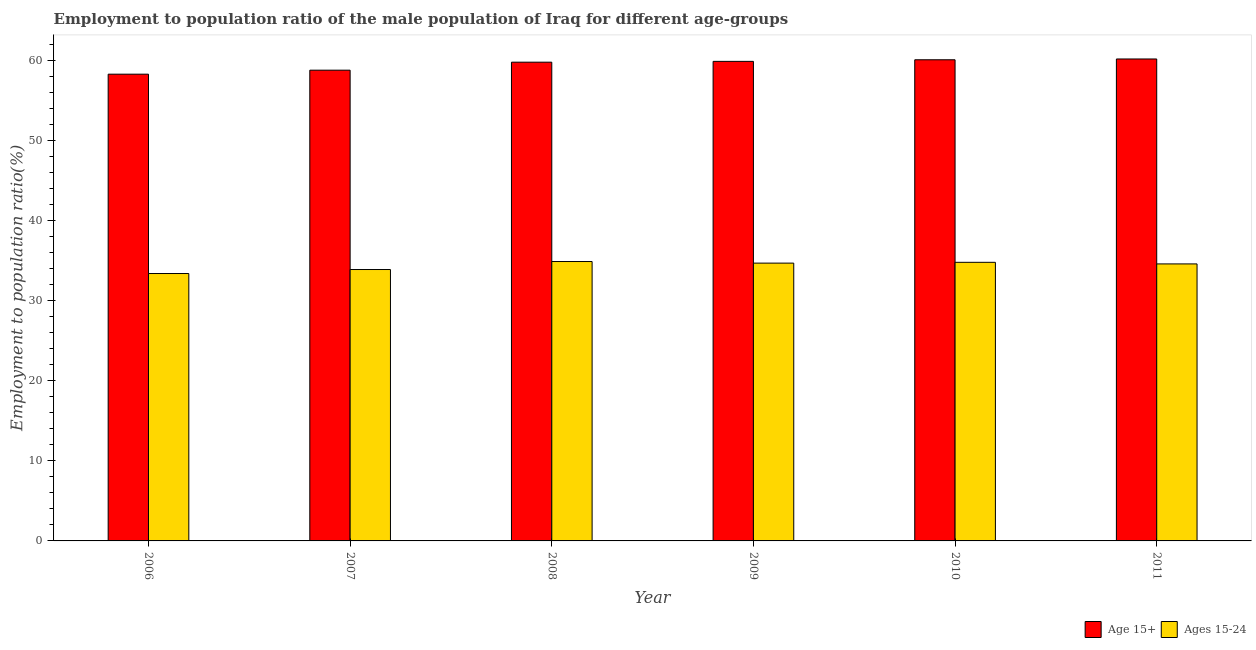How many bars are there on the 3rd tick from the left?
Make the answer very short. 2. How many bars are there on the 2nd tick from the right?
Provide a succinct answer. 2. What is the employment to population ratio(age 15+) in 2009?
Provide a succinct answer. 59.9. Across all years, what is the maximum employment to population ratio(age 15-24)?
Your answer should be very brief. 34.9. Across all years, what is the minimum employment to population ratio(age 15+)?
Ensure brevity in your answer.  58.3. In which year was the employment to population ratio(age 15+) maximum?
Keep it short and to the point. 2011. In which year was the employment to population ratio(age 15-24) minimum?
Keep it short and to the point. 2006. What is the total employment to population ratio(age 15+) in the graph?
Your answer should be very brief. 357.1. What is the difference between the employment to population ratio(age 15-24) in 2010 and that in 2011?
Provide a succinct answer. 0.2. What is the difference between the employment to population ratio(age 15-24) in 2010 and the employment to population ratio(age 15+) in 2007?
Give a very brief answer. 0.9. What is the average employment to population ratio(age 15-24) per year?
Provide a succinct answer. 34.38. In the year 2007, what is the difference between the employment to population ratio(age 15+) and employment to population ratio(age 15-24)?
Ensure brevity in your answer.  0. In how many years, is the employment to population ratio(age 15-24) greater than 28 %?
Provide a succinct answer. 6. What is the ratio of the employment to population ratio(age 15+) in 2007 to that in 2009?
Your answer should be very brief. 0.98. Is the employment to population ratio(age 15-24) in 2006 less than that in 2009?
Keep it short and to the point. Yes. What is the difference between the highest and the second highest employment to population ratio(age 15-24)?
Your answer should be compact. 0.1. What is the difference between the highest and the lowest employment to population ratio(age 15+)?
Your response must be concise. 1.9. Is the sum of the employment to population ratio(age 15-24) in 2006 and 2008 greater than the maximum employment to population ratio(age 15+) across all years?
Your answer should be compact. Yes. What does the 1st bar from the left in 2008 represents?
Your answer should be compact. Age 15+. What does the 1st bar from the right in 2008 represents?
Your response must be concise. Ages 15-24. How many bars are there?
Make the answer very short. 12. How many years are there in the graph?
Provide a short and direct response. 6. Does the graph contain any zero values?
Offer a very short reply. No. Does the graph contain grids?
Keep it short and to the point. No. How are the legend labels stacked?
Your answer should be compact. Horizontal. What is the title of the graph?
Offer a terse response. Employment to population ratio of the male population of Iraq for different age-groups. What is the label or title of the Y-axis?
Keep it short and to the point. Employment to population ratio(%). What is the Employment to population ratio(%) of Age 15+ in 2006?
Offer a very short reply. 58.3. What is the Employment to population ratio(%) of Ages 15-24 in 2006?
Give a very brief answer. 33.4. What is the Employment to population ratio(%) in Age 15+ in 2007?
Provide a short and direct response. 58.8. What is the Employment to population ratio(%) in Ages 15-24 in 2007?
Offer a very short reply. 33.9. What is the Employment to population ratio(%) in Age 15+ in 2008?
Provide a short and direct response. 59.8. What is the Employment to population ratio(%) in Ages 15-24 in 2008?
Ensure brevity in your answer.  34.9. What is the Employment to population ratio(%) of Age 15+ in 2009?
Offer a very short reply. 59.9. What is the Employment to population ratio(%) in Ages 15-24 in 2009?
Provide a short and direct response. 34.7. What is the Employment to population ratio(%) of Age 15+ in 2010?
Offer a very short reply. 60.1. What is the Employment to population ratio(%) of Ages 15-24 in 2010?
Your answer should be very brief. 34.8. What is the Employment to population ratio(%) of Age 15+ in 2011?
Offer a terse response. 60.2. What is the Employment to population ratio(%) of Ages 15-24 in 2011?
Offer a very short reply. 34.6. Across all years, what is the maximum Employment to population ratio(%) in Age 15+?
Keep it short and to the point. 60.2. Across all years, what is the maximum Employment to population ratio(%) of Ages 15-24?
Your answer should be very brief. 34.9. Across all years, what is the minimum Employment to population ratio(%) of Age 15+?
Give a very brief answer. 58.3. Across all years, what is the minimum Employment to population ratio(%) of Ages 15-24?
Offer a terse response. 33.4. What is the total Employment to population ratio(%) of Age 15+ in the graph?
Provide a short and direct response. 357.1. What is the total Employment to population ratio(%) in Ages 15-24 in the graph?
Your answer should be very brief. 206.3. What is the difference between the Employment to population ratio(%) in Age 15+ in 2006 and that in 2008?
Provide a succinct answer. -1.5. What is the difference between the Employment to population ratio(%) of Ages 15-24 in 2006 and that in 2009?
Provide a short and direct response. -1.3. What is the difference between the Employment to population ratio(%) in Age 15+ in 2006 and that in 2010?
Make the answer very short. -1.8. What is the difference between the Employment to population ratio(%) in Ages 15-24 in 2006 and that in 2010?
Your answer should be compact. -1.4. What is the difference between the Employment to population ratio(%) of Ages 15-24 in 2006 and that in 2011?
Your answer should be compact. -1.2. What is the difference between the Employment to population ratio(%) in Age 15+ in 2007 and that in 2008?
Keep it short and to the point. -1. What is the difference between the Employment to population ratio(%) of Ages 15-24 in 2008 and that in 2010?
Keep it short and to the point. 0.1. What is the difference between the Employment to population ratio(%) in Ages 15-24 in 2008 and that in 2011?
Provide a short and direct response. 0.3. What is the difference between the Employment to population ratio(%) in Age 15+ in 2009 and that in 2010?
Provide a succinct answer. -0.2. What is the difference between the Employment to population ratio(%) in Age 15+ in 2010 and that in 2011?
Offer a terse response. -0.1. What is the difference between the Employment to population ratio(%) in Ages 15-24 in 2010 and that in 2011?
Offer a terse response. 0.2. What is the difference between the Employment to population ratio(%) in Age 15+ in 2006 and the Employment to population ratio(%) in Ages 15-24 in 2007?
Ensure brevity in your answer.  24.4. What is the difference between the Employment to population ratio(%) in Age 15+ in 2006 and the Employment to population ratio(%) in Ages 15-24 in 2008?
Your answer should be compact. 23.4. What is the difference between the Employment to population ratio(%) in Age 15+ in 2006 and the Employment to population ratio(%) in Ages 15-24 in 2009?
Provide a succinct answer. 23.6. What is the difference between the Employment to population ratio(%) in Age 15+ in 2006 and the Employment to population ratio(%) in Ages 15-24 in 2010?
Offer a terse response. 23.5. What is the difference between the Employment to population ratio(%) of Age 15+ in 2006 and the Employment to population ratio(%) of Ages 15-24 in 2011?
Your response must be concise. 23.7. What is the difference between the Employment to population ratio(%) in Age 15+ in 2007 and the Employment to population ratio(%) in Ages 15-24 in 2008?
Provide a short and direct response. 23.9. What is the difference between the Employment to population ratio(%) of Age 15+ in 2007 and the Employment to population ratio(%) of Ages 15-24 in 2009?
Give a very brief answer. 24.1. What is the difference between the Employment to population ratio(%) in Age 15+ in 2007 and the Employment to population ratio(%) in Ages 15-24 in 2011?
Your response must be concise. 24.2. What is the difference between the Employment to population ratio(%) in Age 15+ in 2008 and the Employment to population ratio(%) in Ages 15-24 in 2009?
Your response must be concise. 25.1. What is the difference between the Employment to population ratio(%) of Age 15+ in 2008 and the Employment to population ratio(%) of Ages 15-24 in 2010?
Provide a succinct answer. 25. What is the difference between the Employment to population ratio(%) in Age 15+ in 2008 and the Employment to population ratio(%) in Ages 15-24 in 2011?
Keep it short and to the point. 25.2. What is the difference between the Employment to population ratio(%) in Age 15+ in 2009 and the Employment to population ratio(%) in Ages 15-24 in 2010?
Provide a succinct answer. 25.1. What is the difference between the Employment to population ratio(%) in Age 15+ in 2009 and the Employment to population ratio(%) in Ages 15-24 in 2011?
Ensure brevity in your answer.  25.3. What is the difference between the Employment to population ratio(%) of Age 15+ in 2010 and the Employment to population ratio(%) of Ages 15-24 in 2011?
Offer a very short reply. 25.5. What is the average Employment to population ratio(%) of Age 15+ per year?
Give a very brief answer. 59.52. What is the average Employment to population ratio(%) in Ages 15-24 per year?
Your answer should be compact. 34.38. In the year 2006, what is the difference between the Employment to population ratio(%) in Age 15+ and Employment to population ratio(%) in Ages 15-24?
Your response must be concise. 24.9. In the year 2007, what is the difference between the Employment to population ratio(%) of Age 15+ and Employment to population ratio(%) of Ages 15-24?
Provide a short and direct response. 24.9. In the year 2008, what is the difference between the Employment to population ratio(%) of Age 15+ and Employment to population ratio(%) of Ages 15-24?
Your answer should be very brief. 24.9. In the year 2009, what is the difference between the Employment to population ratio(%) in Age 15+ and Employment to population ratio(%) in Ages 15-24?
Ensure brevity in your answer.  25.2. In the year 2010, what is the difference between the Employment to population ratio(%) in Age 15+ and Employment to population ratio(%) in Ages 15-24?
Ensure brevity in your answer.  25.3. In the year 2011, what is the difference between the Employment to population ratio(%) in Age 15+ and Employment to population ratio(%) in Ages 15-24?
Give a very brief answer. 25.6. What is the ratio of the Employment to population ratio(%) in Age 15+ in 2006 to that in 2007?
Your answer should be very brief. 0.99. What is the ratio of the Employment to population ratio(%) of Ages 15-24 in 2006 to that in 2007?
Provide a succinct answer. 0.99. What is the ratio of the Employment to population ratio(%) in Age 15+ in 2006 to that in 2008?
Your answer should be very brief. 0.97. What is the ratio of the Employment to population ratio(%) in Age 15+ in 2006 to that in 2009?
Ensure brevity in your answer.  0.97. What is the ratio of the Employment to population ratio(%) in Ages 15-24 in 2006 to that in 2009?
Give a very brief answer. 0.96. What is the ratio of the Employment to population ratio(%) in Ages 15-24 in 2006 to that in 2010?
Your answer should be compact. 0.96. What is the ratio of the Employment to population ratio(%) of Age 15+ in 2006 to that in 2011?
Offer a terse response. 0.97. What is the ratio of the Employment to population ratio(%) of Ages 15-24 in 2006 to that in 2011?
Give a very brief answer. 0.97. What is the ratio of the Employment to population ratio(%) of Age 15+ in 2007 to that in 2008?
Make the answer very short. 0.98. What is the ratio of the Employment to population ratio(%) of Ages 15-24 in 2007 to that in 2008?
Ensure brevity in your answer.  0.97. What is the ratio of the Employment to population ratio(%) of Age 15+ in 2007 to that in 2009?
Offer a terse response. 0.98. What is the ratio of the Employment to population ratio(%) of Ages 15-24 in 2007 to that in 2009?
Provide a succinct answer. 0.98. What is the ratio of the Employment to population ratio(%) of Age 15+ in 2007 to that in 2010?
Offer a very short reply. 0.98. What is the ratio of the Employment to population ratio(%) of Ages 15-24 in 2007 to that in 2010?
Make the answer very short. 0.97. What is the ratio of the Employment to population ratio(%) in Age 15+ in 2007 to that in 2011?
Offer a very short reply. 0.98. What is the ratio of the Employment to population ratio(%) in Ages 15-24 in 2007 to that in 2011?
Ensure brevity in your answer.  0.98. What is the ratio of the Employment to population ratio(%) in Age 15+ in 2008 to that in 2009?
Give a very brief answer. 1. What is the ratio of the Employment to population ratio(%) of Ages 15-24 in 2008 to that in 2009?
Give a very brief answer. 1.01. What is the ratio of the Employment to population ratio(%) in Ages 15-24 in 2008 to that in 2011?
Your answer should be very brief. 1.01. What is the ratio of the Employment to population ratio(%) in Ages 15-24 in 2009 to that in 2011?
Give a very brief answer. 1. What is the ratio of the Employment to population ratio(%) of Ages 15-24 in 2010 to that in 2011?
Offer a very short reply. 1.01. What is the difference between the highest and the second highest Employment to population ratio(%) of Age 15+?
Your answer should be compact. 0.1. What is the difference between the highest and the second highest Employment to population ratio(%) of Ages 15-24?
Offer a terse response. 0.1. What is the difference between the highest and the lowest Employment to population ratio(%) of Age 15+?
Keep it short and to the point. 1.9. What is the difference between the highest and the lowest Employment to population ratio(%) of Ages 15-24?
Make the answer very short. 1.5. 